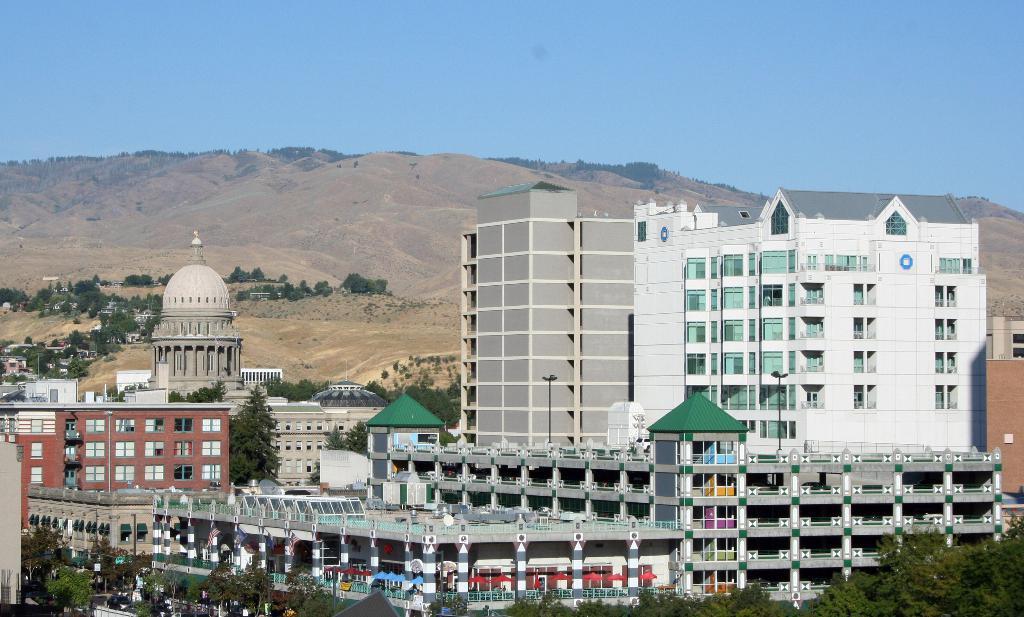How would you summarize this image in a sentence or two? At the bottom of the image we can see some trees and buildings. Behind the buildings we can see a hill. At the top of the image we can see the sky. 